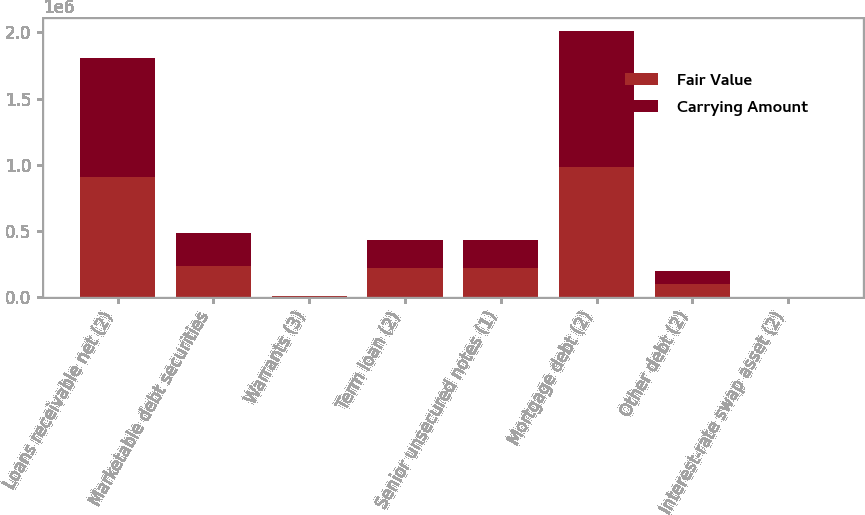Convert chart to OTSL. <chart><loc_0><loc_0><loc_500><loc_500><stacked_bar_chart><ecel><fcel>Loans receivable net (2)<fcel>Marketable debt securities<fcel>Warrants (3)<fcel>Term loan (2)<fcel>Senior unsecured notes (1)<fcel>Mortgage debt (2)<fcel>Other debt (2)<fcel>Interest-rate swap asset (2)<nl><fcel>Fair Value<fcel>906961<fcel>231442<fcel>2220<fcel>213610<fcel>213610<fcel>984431<fcel>97022<fcel>178<nl><fcel>Carrying Amount<fcel>898522<fcel>252125<fcel>2220<fcel>213610<fcel>213610<fcel>1.02509e+06<fcel>97022<fcel>178<nl></chart> 